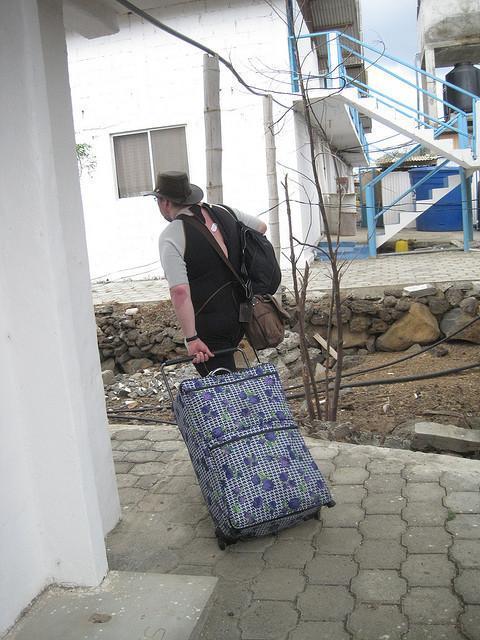How many handbags can be seen?
Give a very brief answer. 2. How many cars are there?
Give a very brief answer. 0. 